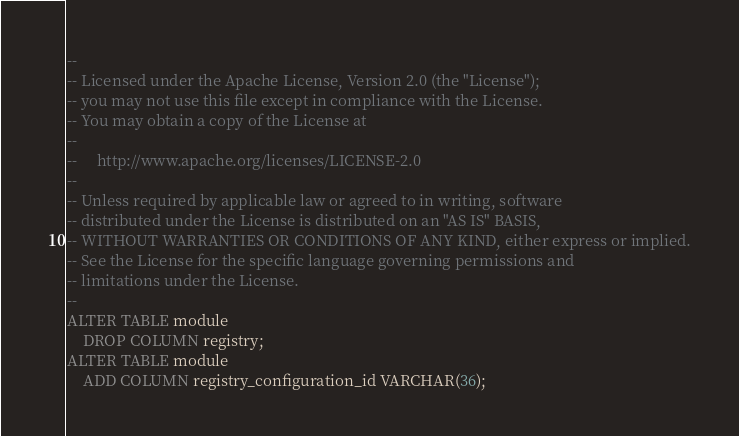Convert code to text. <code><loc_0><loc_0><loc_500><loc_500><_SQL_>--
-- Licensed under the Apache License, Version 2.0 (the "License");
-- you may not use this file except in compliance with the License.
-- You may obtain a copy of the License at
--
--     http://www.apache.org/licenses/LICENSE-2.0
--
-- Unless required by applicable law or agreed to in writing, software
-- distributed under the License is distributed on an "AS IS" BASIS,
-- WITHOUT WARRANTIES OR CONDITIONS OF ANY KIND, either express or implied.
-- See the License for the specific language governing permissions and
-- limitations under the License.
--
ALTER TABLE module
    DROP COLUMN registry;
ALTER TABLE module
    ADD COLUMN registry_configuration_id VARCHAR(36);</code> 